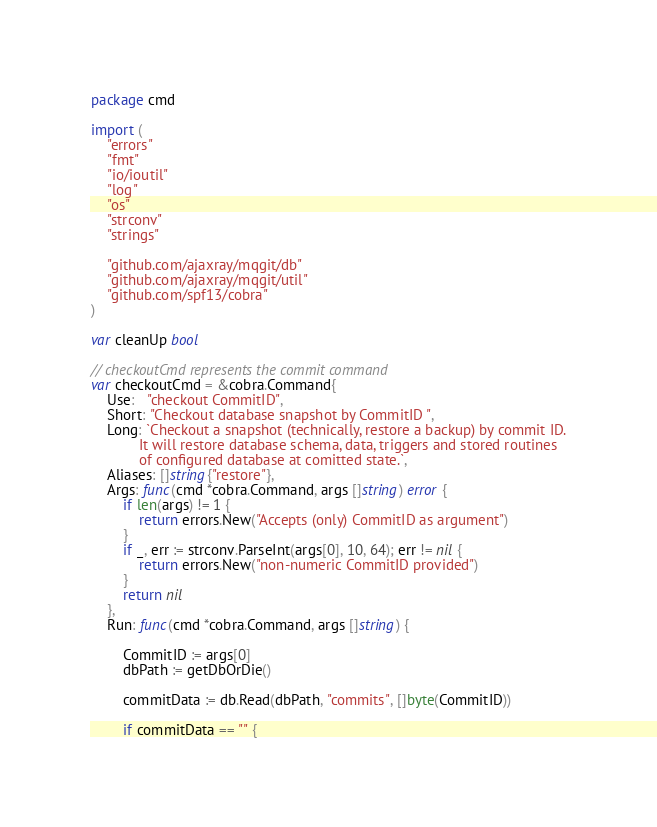Convert code to text. <code><loc_0><loc_0><loc_500><loc_500><_Go_>
package cmd

import (
	"errors"
	"fmt"
	"io/ioutil"
	"log"
	"os"
	"strconv"
	"strings"

	"github.com/ajaxray/mqgit/db"
	"github.com/ajaxray/mqgit/util"
	"github.com/spf13/cobra"
)

var cleanUp bool

// checkoutCmd represents the commit command
var checkoutCmd = &cobra.Command{
	Use:   "checkout CommitID",
	Short: "Checkout database snapshot by CommitID ",
	Long: `Checkout a snapshot (technically, restore a backup) by commit ID.
			It will restore database schema, data, triggers and stored routines 
			of configured database at comitted state.`,
	Aliases: []string{"restore"},
	Args: func(cmd *cobra.Command, args []string) error {
		if len(args) != 1 {
			return errors.New("Accepts (only) CommitID as argument")
		}
		if _, err := strconv.ParseInt(args[0], 10, 64); err != nil {
			return errors.New("non-numeric CommitID provided")
		}
		return nil
	},
	Run: func(cmd *cobra.Command, args []string) {

		CommitID := args[0]
		dbPath := getDbOrDie()

		commitData := db.Read(dbPath, "commits", []byte(CommitID))

		if commitData == "" {</code> 